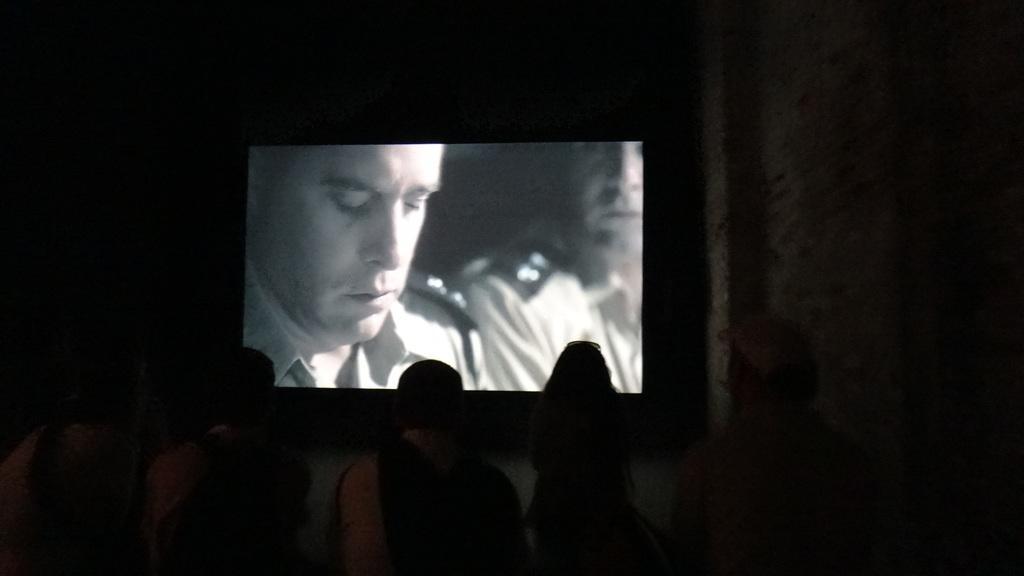Please provide a concise description of this image. In this picture we can see a group of people and in front of them we can see a screen and in the background it is dark. 